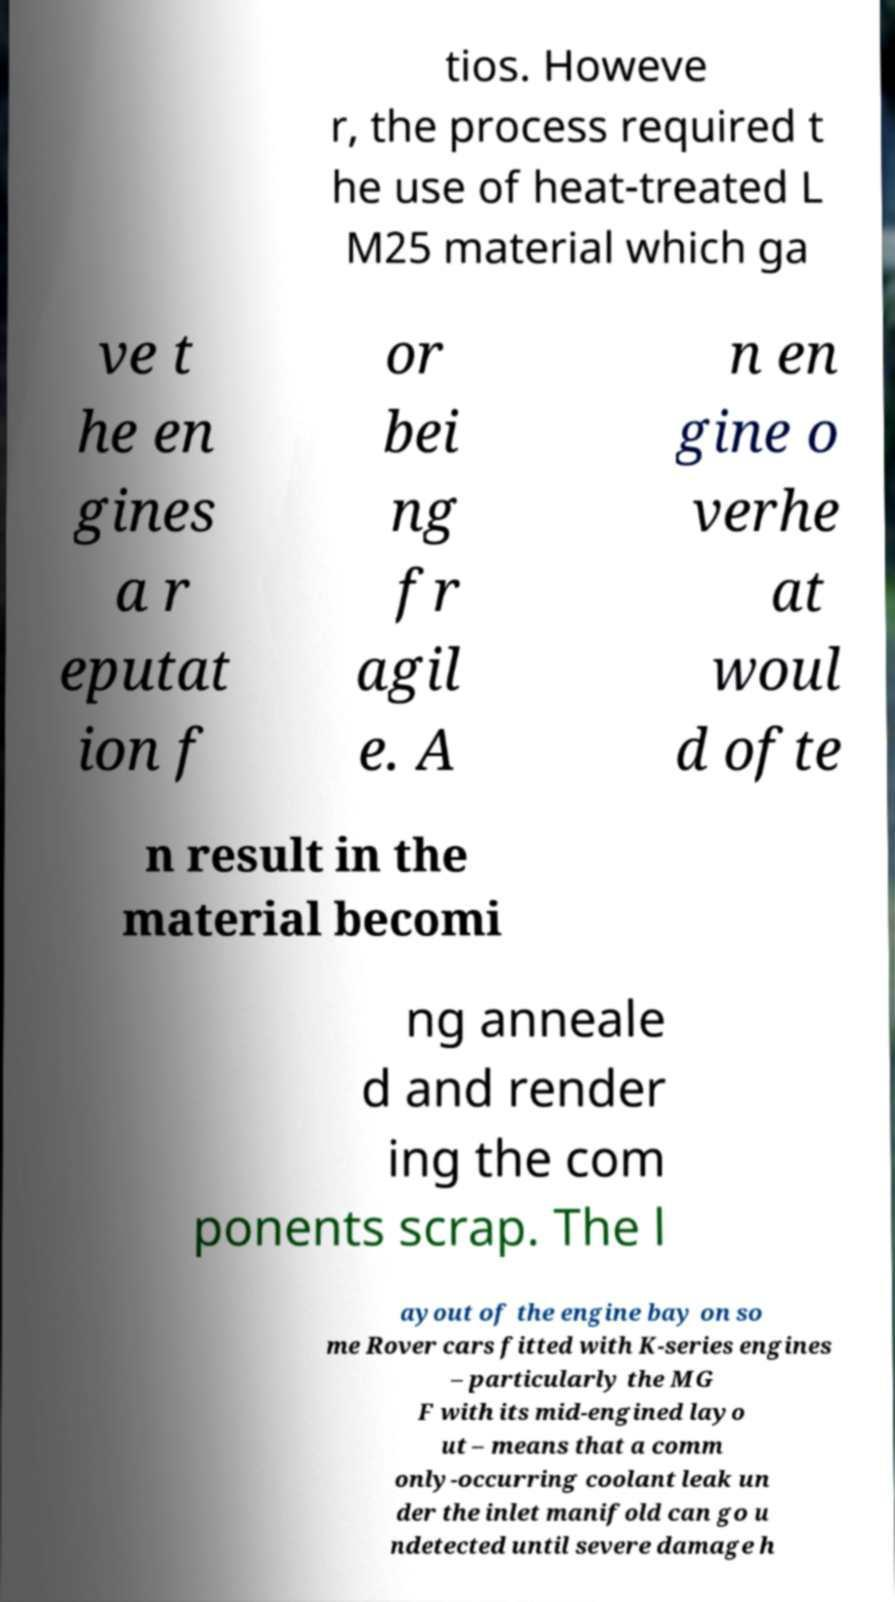Could you assist in decoding the text presented in this image and type it out clearly? tios. Howeve r, the process required t he use of heat-treated L M25 material which ga ve t he en gines a r eputat ion f or bei ng fr agil e. A n en gine o verhe at woul d ofte n result in the material becomi ng anneale d and render ing the com ponents scrap. The l ayout of the engine bay on so me Rover cars fitted with K-series engines – particularly the MG F with its mid-engined layo ut – means that a comm only-occurring coolant leak un der the inlet manifold can go u ndetected until severe damage h 